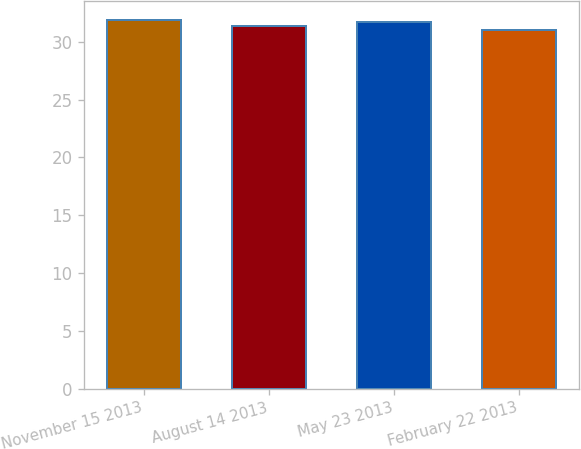Convert chart to OTSL. <chart><loc_0><loc_0><loc_500><loc_500><bar_chart><fcel>November 15 2013<fcel>August 14 2013<fcel>May 23 2013<fcel>February 22 2013<nl><fcel>31.9<fcel>31.4<fcel>31.7<fcel>31<nl></chart> 